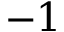<formula> <loc_0><loc_0><loc_500><loc_500>- 1</formula> 